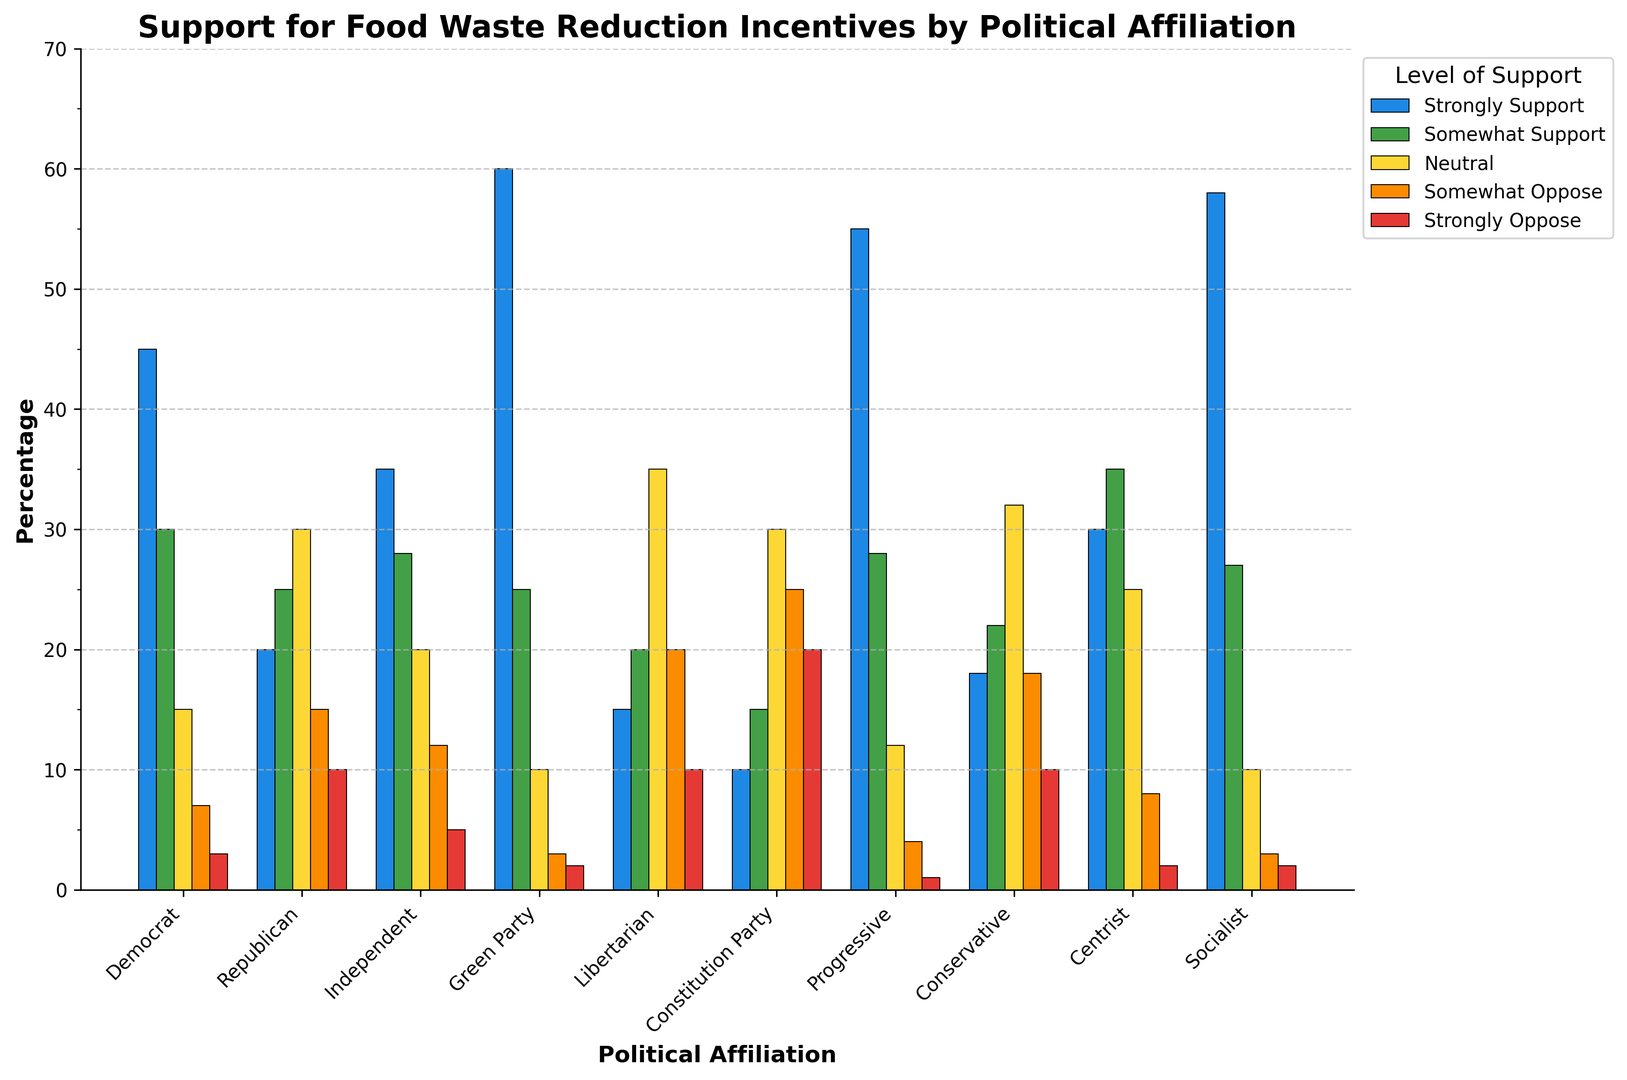How many officials from the Green Party somewhat or strongly support food waste reduction incentives? Sum the Green Party officials who "Strongly Support" (60) and "Somewhat Support" (25): 60 + 25 = 85
Answer: 85 Which political affiliation has the highest percentage of officials who strongly oppose food waste reduction incentives? Identify the highest value in the "Strongly Oppose" category across all affiliations, which is 20 (Constitution Party and Libertarian). The Constitution Party reaches this value first.
Answer: Constitution Party Comparing Democrat and Republican officials, which group has a higher percentage of officials that somewhat support food waste reduction incentives? Compare the percentage values of the "Somewhat Support" category: Democrat (30) and Republican (25). Democrat has a higher value.
Answer: Democrat What's the total percentage of Progressive officials who either strongly or somewhat oppose food waste reduction incentives? Sum the values "Strongly Oppose" (1) and "Somewhat Oppose" (4) for Progressive: 1 + 4 = 5
Answer: 5 What is the average percentage of officials who are neutral across all affiliations? Sum the "Neutral" category values for all affiliations and divide by the number of affiliations: (15 + 30 + 20 + 10 + 35 + 30 + 12 + 32 + 25 + 10) / 10 = 239 / 10 = 23.9
Answer: 23.9 How does the attitude towards food waste reduction incentives of Independent officials compare to that of Socialist officials in terms of somewhat oppose and strongly oppose? Compare "Somewhat Oppose" (Independent: 12, Socialist: 3) and "Strongly Oppose" values (Independent: 5, Socialist: 2). Officials from Independent show higher opposition in both categories.
Answer: Independent Which political affiliation has the broadest distribution (highest range) in the level of support for food waste reduction incentives? Calculate the range (difference between highest and lowest values) for each affiliation. The largest difference is 60 - 1 = 59 for Progressive.
Answer: Progressive How many groups have more than 50% of officials strongly supporting food waste reduction incentives? Identify the groups with "Strongly Support" values greater than 50: Green Party (60), Progressive (55), and Socialist (58), resulting in 3 groups.
Answer: 3 What is the combined percentage of Centrist and Conservative officials who are neutral towards food waste reduction incentives? Sum the "Neutral" values for Centrist (25) and Conservative (32): 25 + 32 = 57
Answer: 57 